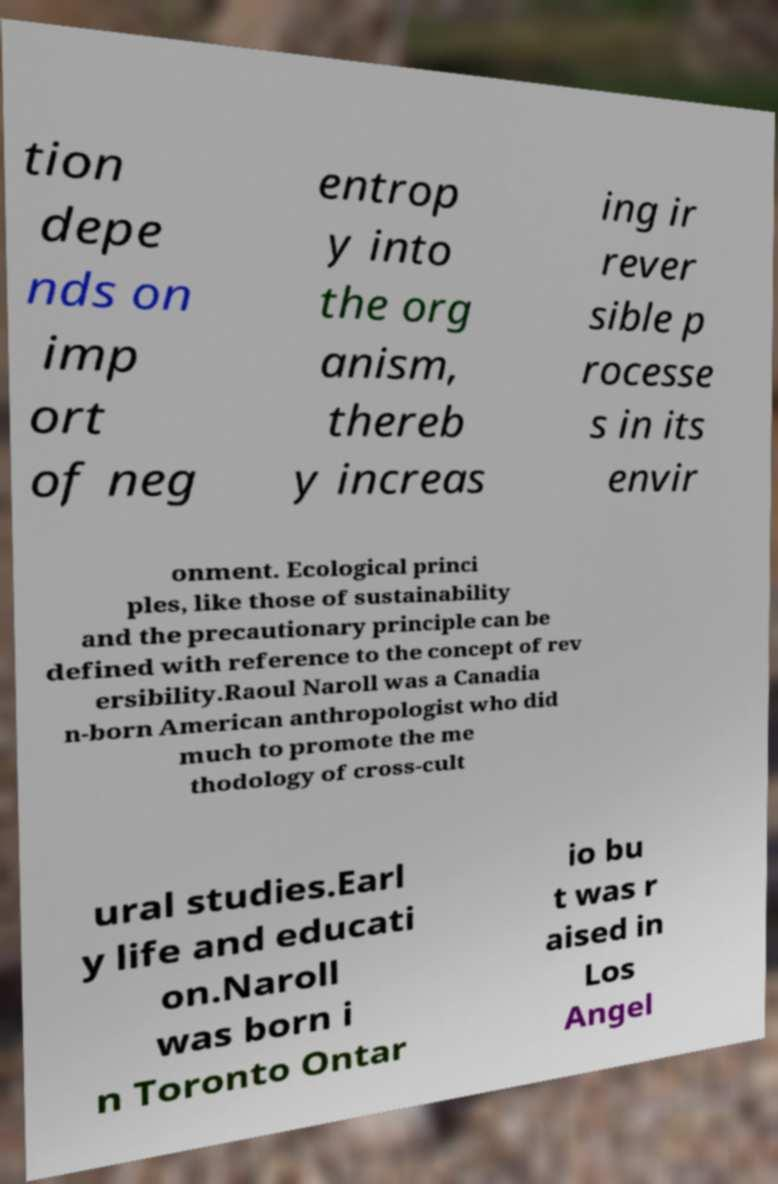Could you assist in decoding the text presented in this image and type it out clearly? tion depe nds on imp ort of neg entrop y into the org anism, thereb y increas ing ir rever sible p rocesse s in its envir onment. Ecological princi ples, like those of sustainability and the precautionary principle can be defined with reference to the concept of rev ersibility.Raoul Naroll was a Canadia n-born American anthropologist who did much to promote the me thodology of cross-cult ural studies.Earl y life and educati on.Naroll was born i n Toronto Ontar io bu t was r aised in Los Angel 